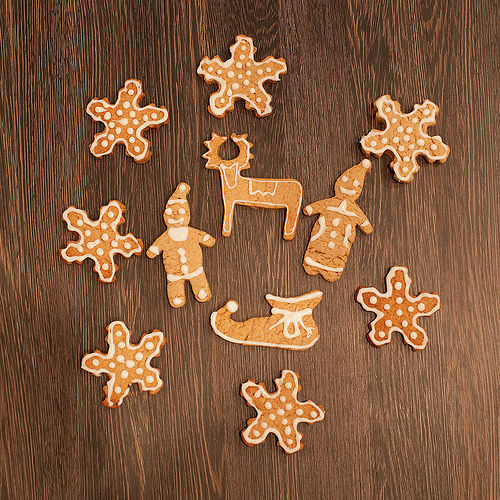<image>
Is the shoe in front of the cookie? No. The shoe is not in front of the cookie. The spatial positioning shows a different relationship between these objects. Is there a star cookie above the reindeer cookie? No. The star cookie is not positioned above the reindeer cookie. The vertical arrangement shows a different relationship. 